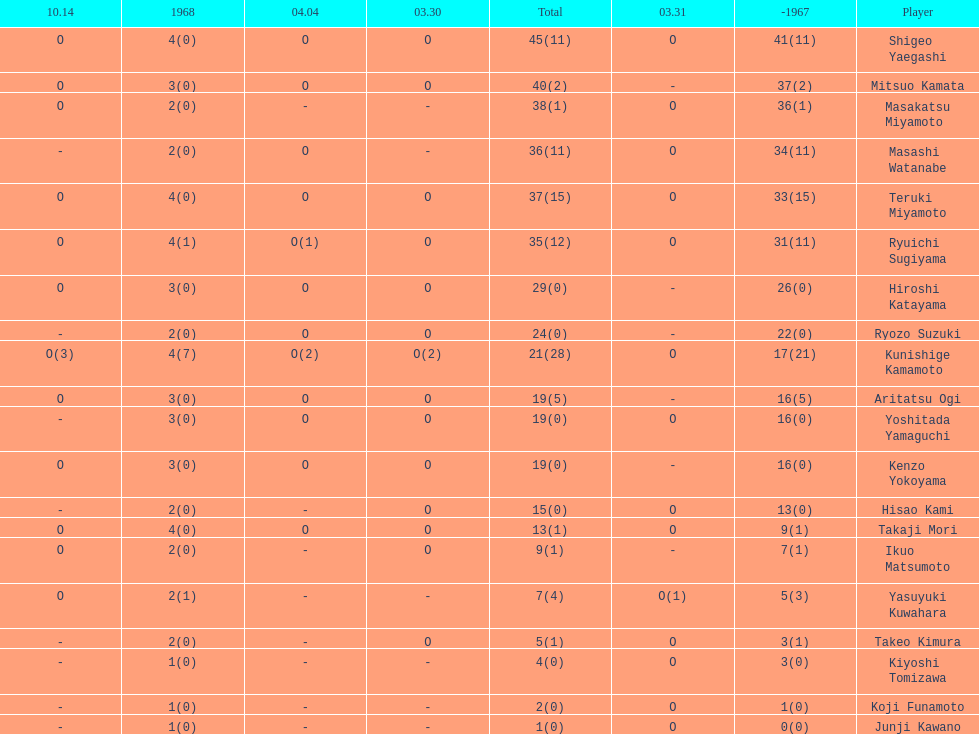How many more total appearances did shigeo yaegashi have than mitsuo kamata? 5. 